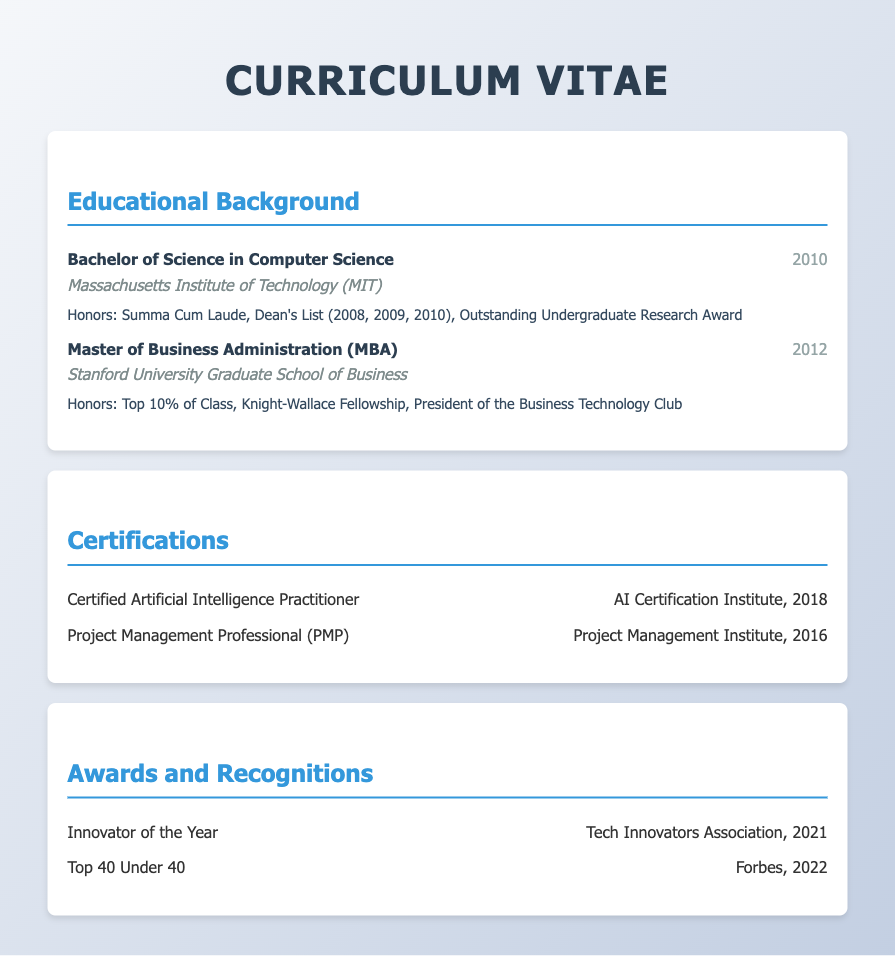what degree was awarded by MIT? The document states that a Bachelor of Science in Computer Science was awarded by MIT.
Answer: Bachelor of Science in Computer Science what is the year of the MBA? The document indicates that the Master of Business Administration was completed in 2012.
Answer: 2012 which award was received in 2021? According to the document, the award received in 2021 was Innovator of the Year.
Answer: Innovator of the Year what honors did the MBA recipient achieve? The document lists that the MBA recipient was in the top 10% of the class and received additional honors as President of the Business Technology Club.
Answer: Top 10% of Class, President of the Business Technology Club how many years apart are the undergraduate and MBA degrees? The document reveals that the undergraduate degree was awarded in 2010 and the MBA in 2012, indicating a two-year gap.
Answer: 2 years who was the institution for the Computer Science degree? The document specifies that the Bachelor of Science in Computer Science was awarded by the Massachusetts Institute of Technology.
Answer: Massachusetts Institute of Technology which fellowship is mentioned in the educational background? The document mentions the Knight-Wallace Fellowship received during the MBA program.
Answer: Knight-Wallace Fellowship what is the title of the section that lists certifications? The title of the section containing certifications is "Certifications."
Answer: Certifications 